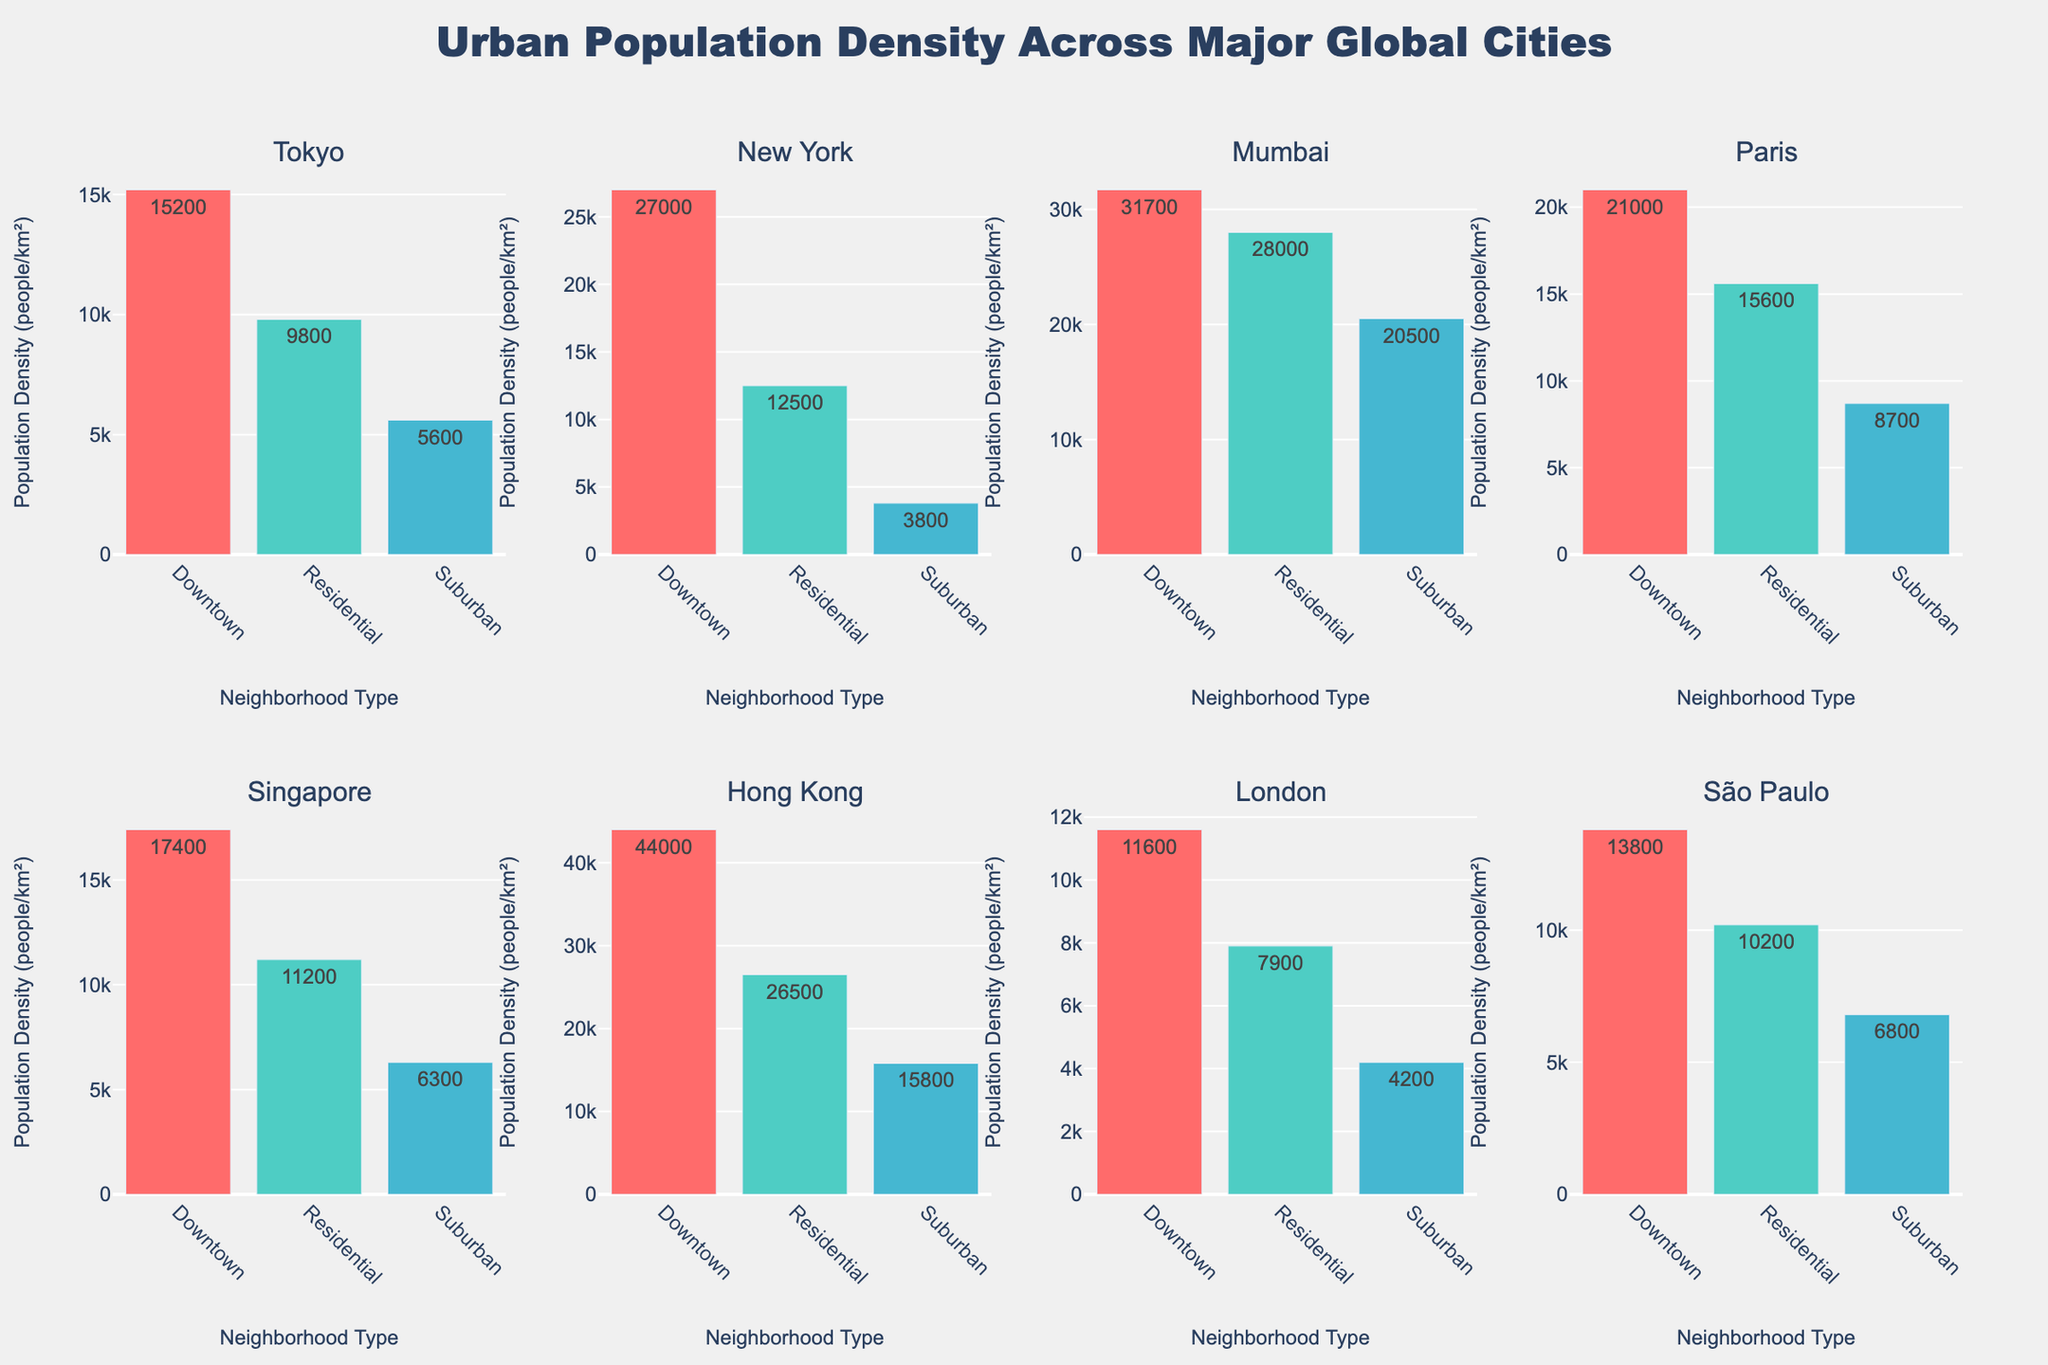What's the title of the figure? The title is usually placed at the top of the figure. In this case, the title reads "Urban Population Density Across Major Global Cities," indicating the figure's main topic.
Answer: Urban Population Density Across Major Global Cities Which city has the highest population density in downtown areas? To find this, look at the bars representing downtown areas for each city. The tallest bar corresponds to Hong Kong, showing 44,000 people per km².
Answer: Hong Kong What is the difference in population density between suburban and downtown areas in New York? Locate the bars for New York and compare the height of the downtown and suburban bars. Subtract the suburban density (3,800 people/km²) from the downtown density (27,000 people/km²).
Answer: 23,200 people/km² In which city do suburban areas have a higher population density than the downtown area of London? Locate London's downtown population density (11,600 people/km²) and compare it with all cities' suburban bars. Mumbai's suburban density (20,500 people/km²) is higher.
Answer: Mumbai How does the population density in residential areas of São Paulo compare with that in residential areas of Singapore? Find the residential bars for both São Paulo (10,200 people/km²) and Singapore (11,200 people/km²). Compare the two values. São Paulo has slightly lower density.
Answer: Lower Which neighborhood type has the most similar population density across all cities? Observe the bars for each neighborhood type across all cities. Residential areas have relatively less variation compared to downtown or suburban areas.
Answer: Residential What is the average population density across all neighborhoods in Paris? Calculate by adding Paris's neighborhood densities (21,000 + 15,600 + 8,700) and then divide by 3. (21,000 + 15,600 + 8,700) / 3 = 15,766.67 people/km².
Answer: 15,767 people/km² Between Tokyo and London, which city has a higher residential population density? Compare the residential bars for Tokyo (9,800 people/km²) and London (7,900 people/km²). Tokyo is higher.
Answer: Tokyo Which two cities have the closest population densities in downtown areas? Find and compare the values of downtown areas for each city. São Paulo (13,800 people/km²) and London (11,600 people/km²) are reasonably close in values.
Answer: São Paulo and London 